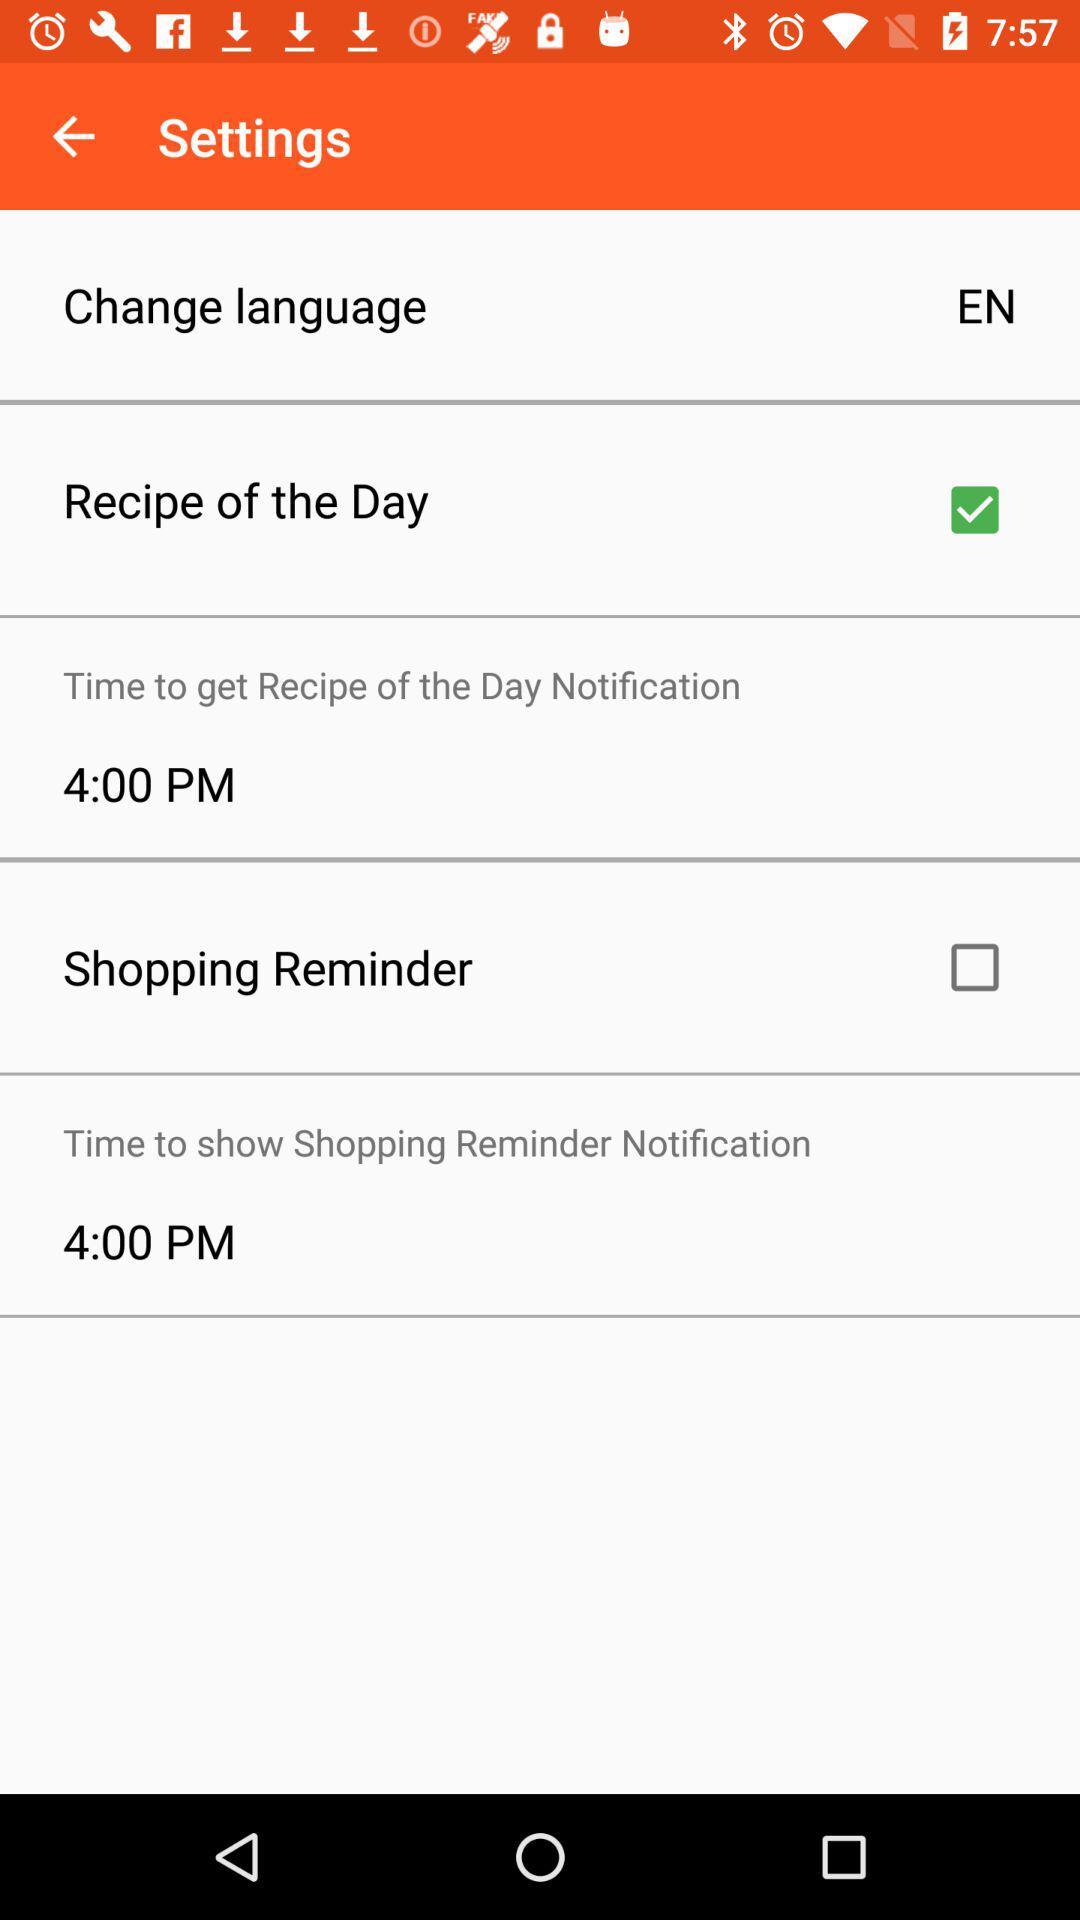What language is selected? The selected language is English. 